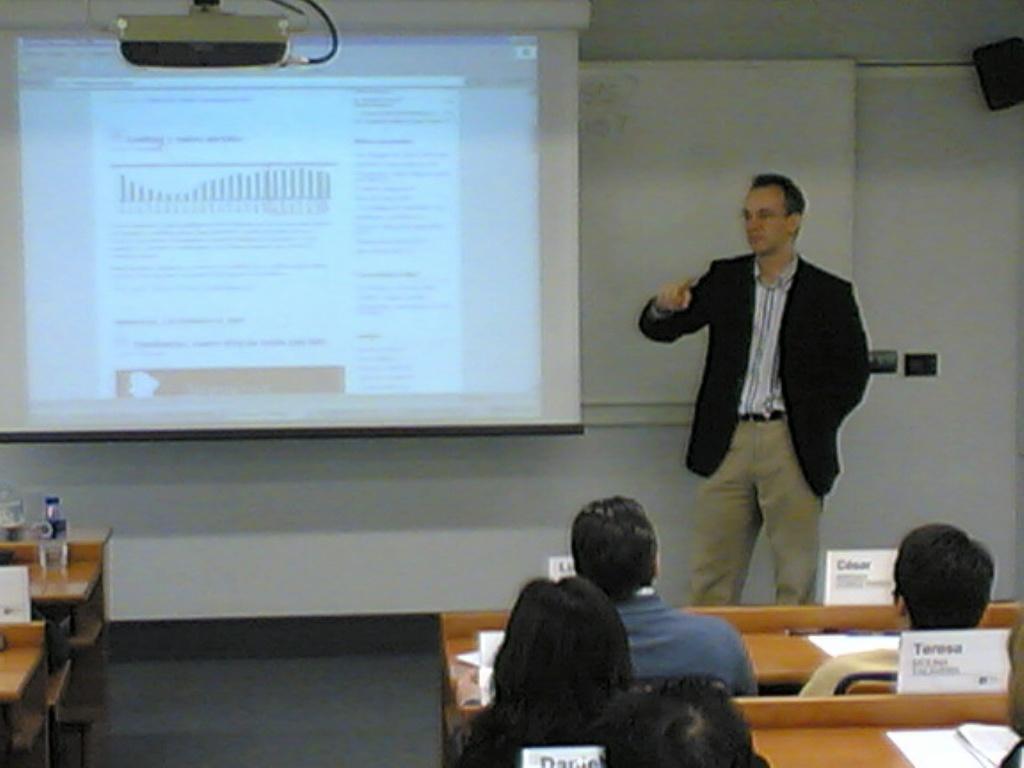Please provide a concise description of this image. In this image, we can see a person is standing beside the screen. Background there is a board, wall, speaker, few objects. Top of the image, there is a projector. At the bottom, we can see the floor, few people are sitting on the benches. Here we can see few objects and bottles. 